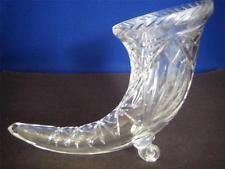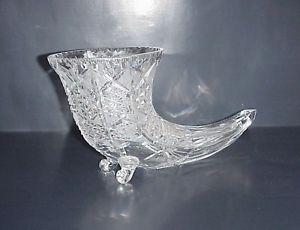The first image is the image on the left, the second image is the image on the right. Given the left and right images, does the statement "The left and right image contains the same number of glass horn vases." hold true? Answer yes or no. Yes. The first image is the image on the left, the second image is the image on the right. Examine the images to the left and right. Is the description "There is exactly one curved glass vase is shown in every photograph and in every photo the entire vase is visible." accurate? Answer yes or no. Yes. 